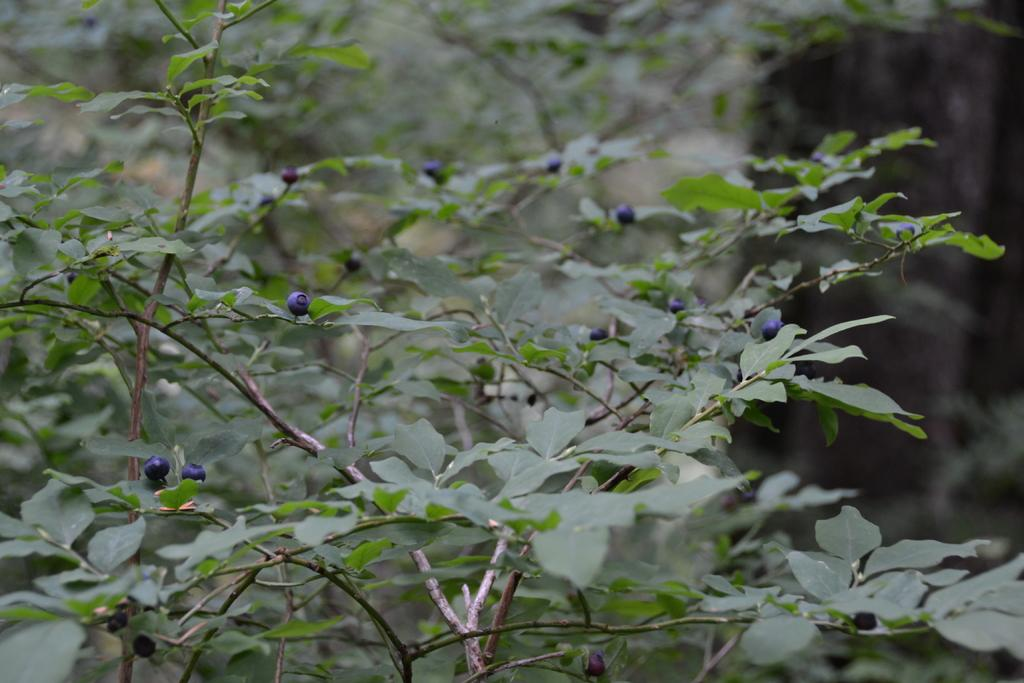What is the main subject of the image? The main subject of the image is a tree with fruits. Can you describe the background of the image? The background of the image is slightly blurred. What type of whistle can be heard in the image? There is no whistle present in the image, as it is a still photograph and cannot produce sound. 